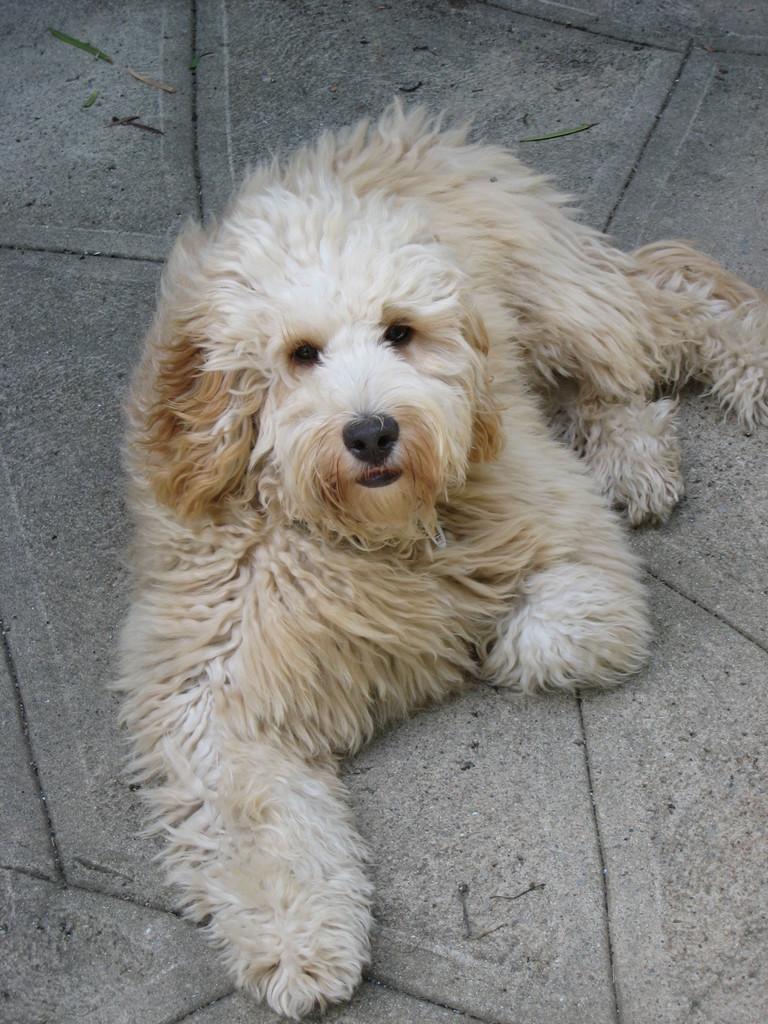Please provide a concise description of this image. In the picture we can see white and brown color dog which is resting on ground. 